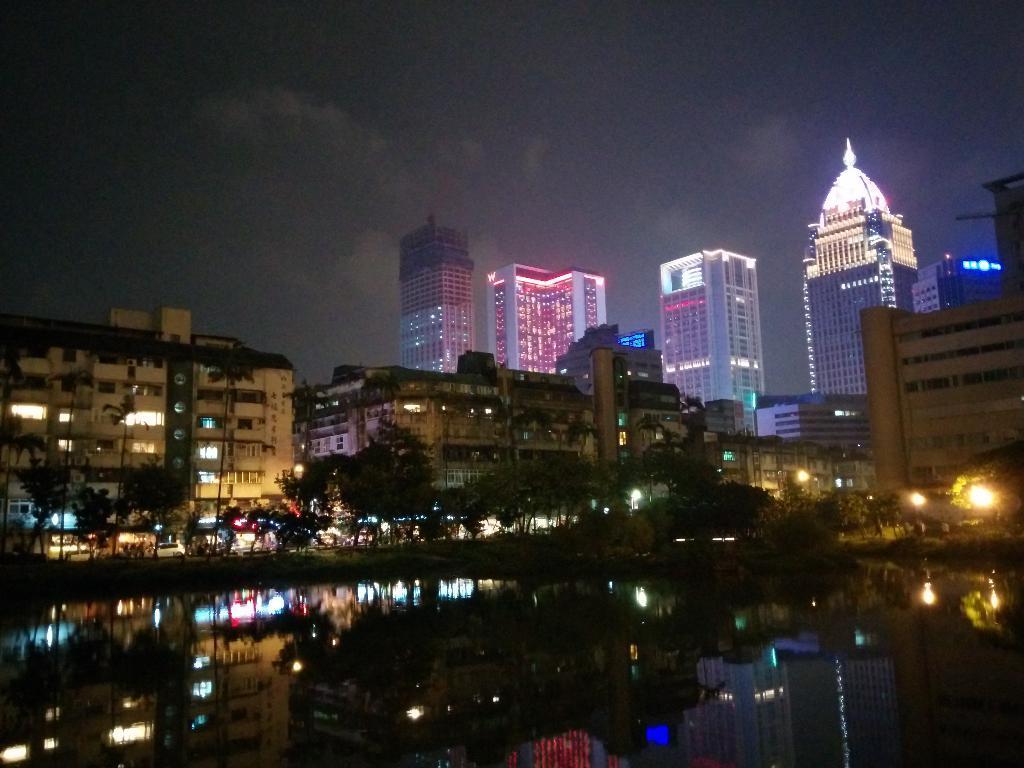Could you give a brief overview of what you see in this image? In this picture we can see water at the bottom, in the background there are some buildings, trees and lights, there is the sky at the top of the picture. 